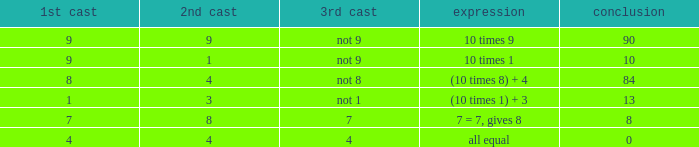If the equation is (10 times 1) + 3, what is the 2nd throw? 3.0. 